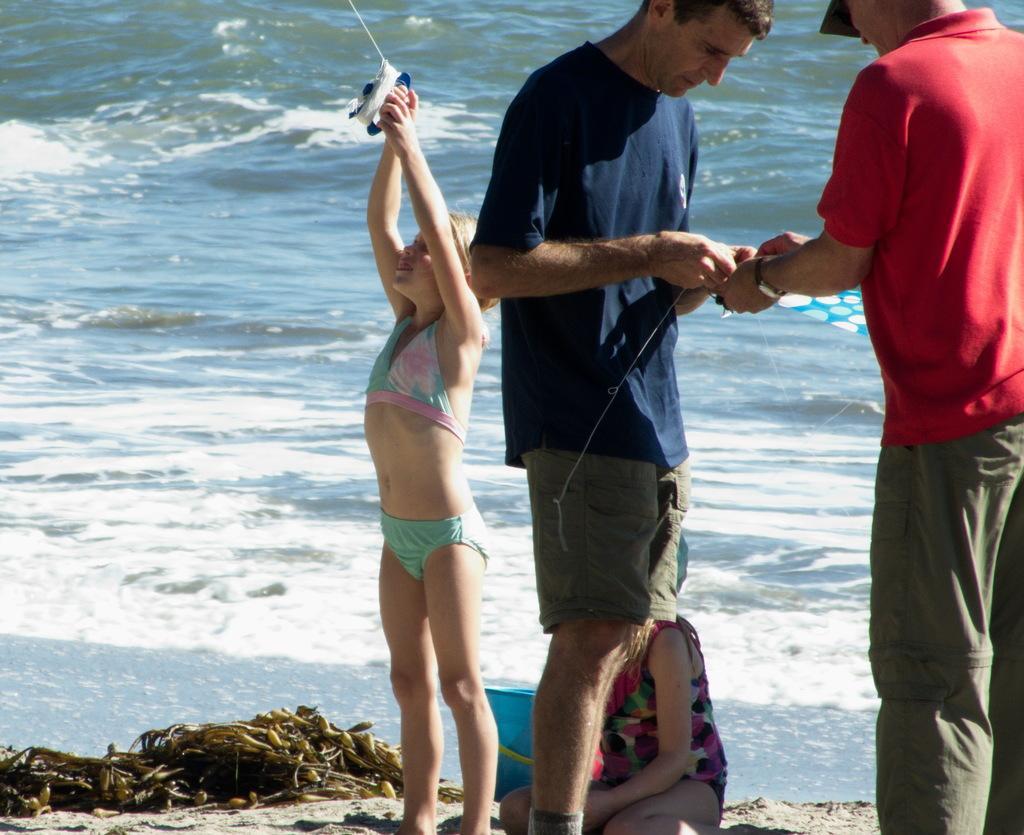Describe this image in one or two sentences. In this picture I see 2 men in front who are standing and holding a thing in their hands and behind them I see 2 girls and I see a bucket behind the girls. In the background I see the water and I see that this girl on the left is holding a thing. 